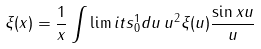Convert formula to latex. <formula><loc_0><loc_0><loc_500><loc_500>\xi ( x ) = \frac { 1 } { x } \int \lim i t s _ { 0 } ^ { 1 } d u \, u ^ { 2 } \xi ( u ) \frac { \sin x u } u</formula> 